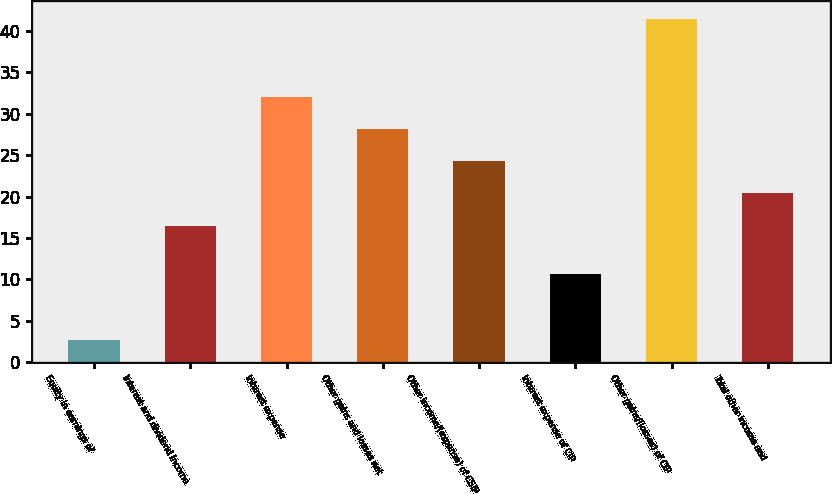<chart> <loc_0><loc_0><loc_500><loc_500><bar_chart><fcel>Equity in earnings of<fcel>Interest and dividend income<fcel>Interest expense<fcel>Other gains and losses net<fcel>Other income/(expense) of CSIP<fcel>Interest expense of CIP<fcel>Other gains/(losses) of CIP<fcel>Total other income and<nl><fcel>2.7<fcel>16.5<fcel>32.02<fcel>28.14<fcel>24.26<fcel>10.6<fcel>41.5<fcel>20.38<nl></chart> 